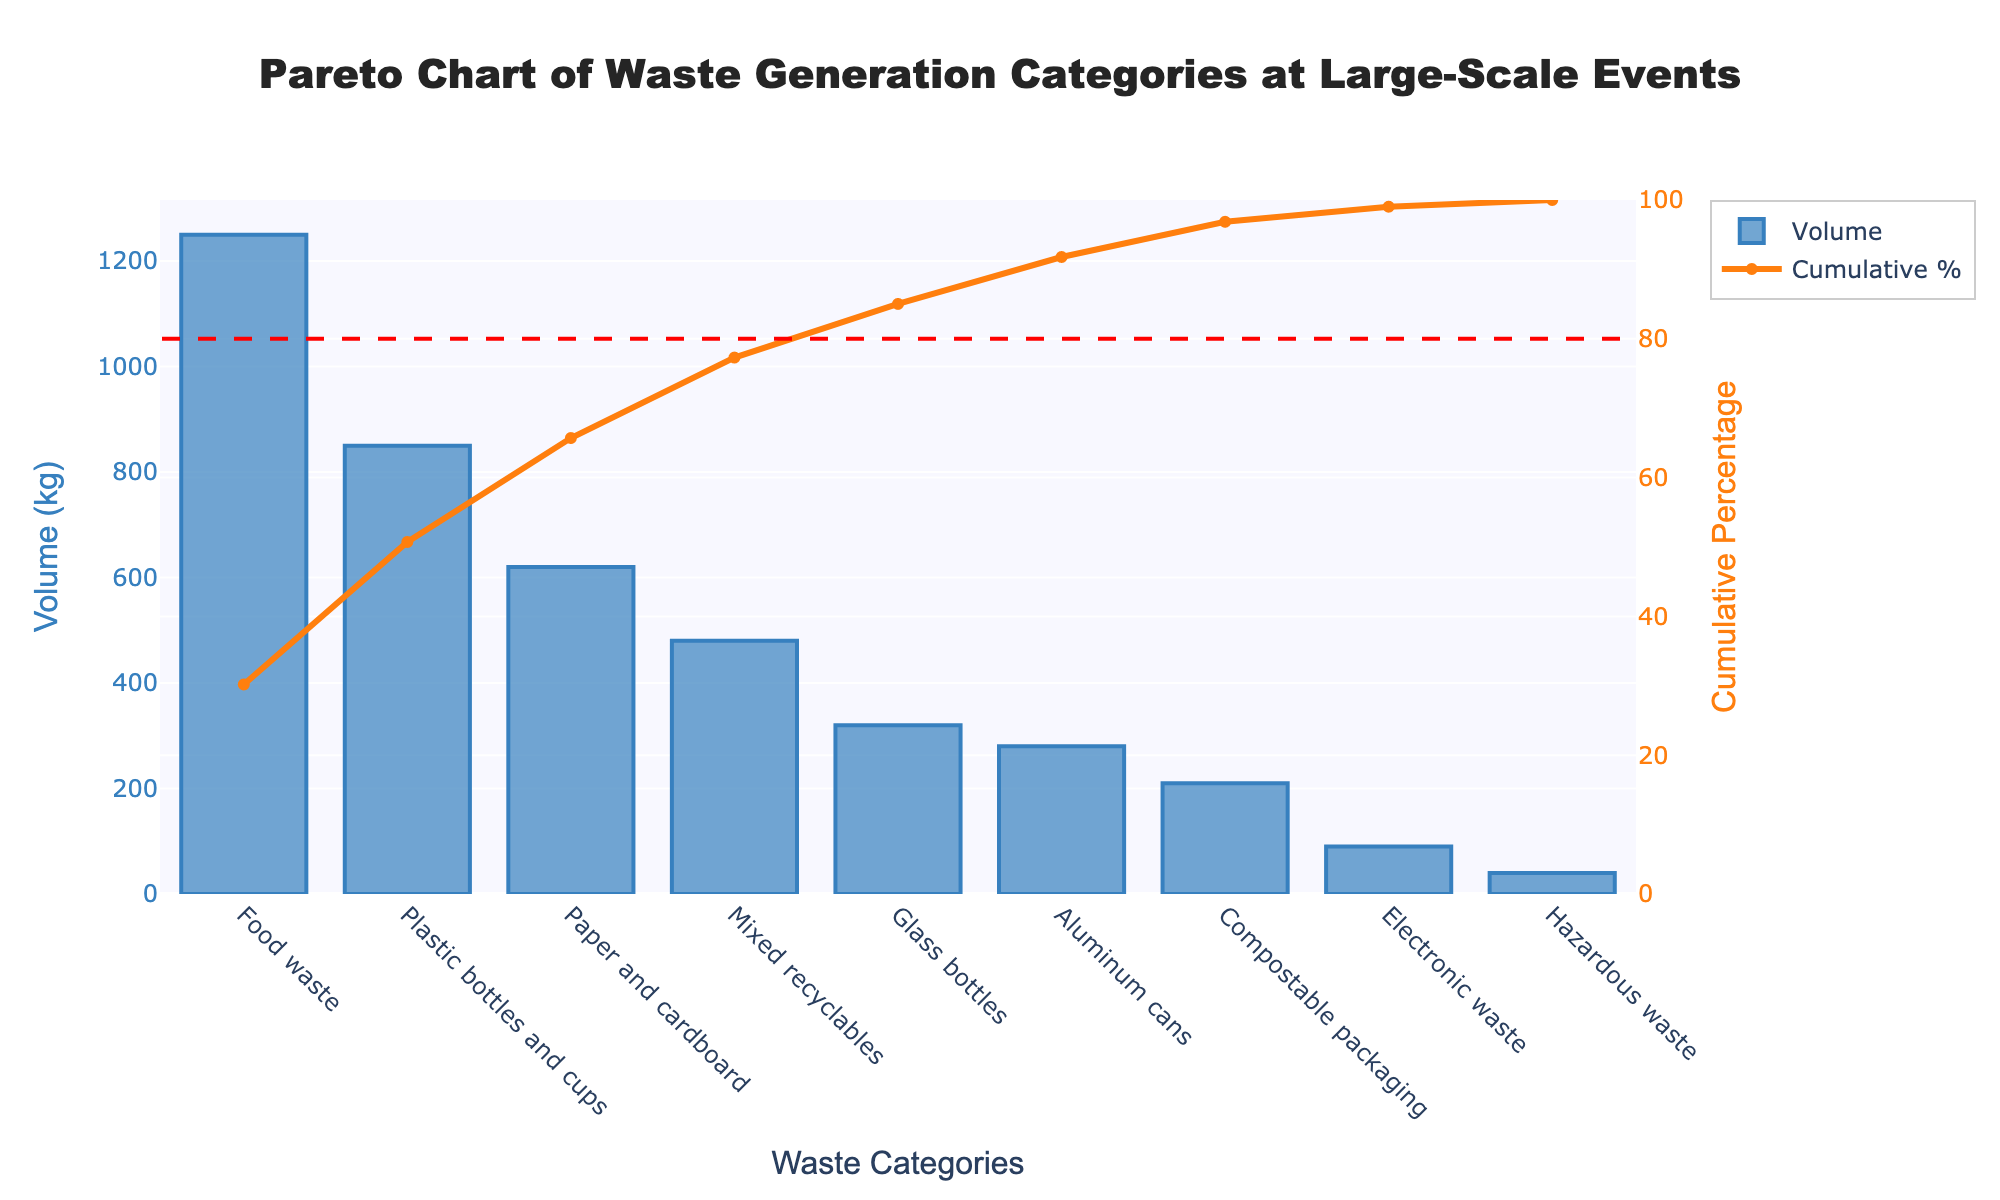Which waste category has the highest volume? Look at the bars in the Pareto chart and identify the one with the largest height. The highest volume category is Food waste.
Answer: Food waste What is the cumulative percentage for Plastic bottles and cups? Find the cumulative percentage value corresponding to Plastic bottles and cups. This value is given on the secondary y-axis (Cumulative Percentage).
Answer: 54.84% Which waste category has the lowest volume? Look at the bars and identify the one with the smallest height. The lowest volume corresponds to Electronic waste.
Answer: Electronic waste What is the total volume of Food waste and Plastic bottles and cups combined? Locate the volumes for Food waste and Plastic bottles and cups. Summing these values: 1250 (Food waste) + 850 (Plastic bottles and cups) = 2100 kg.
Answer: 2100 kg Which three categories together account for approximately 80% of the waste? Find the categories whose cumulative percentage total is closest to 80%. The cumulative percentages are: Food waste (35.56%), Plastic bottles and cups (54.84%), and Paper and cardboard (72.44%). Adding these, they account for approximately 80%.
Answer: Food waste, Plastic bottles and cups, Paper and cardboard How much more waste does Mixed recyclables generate compared to Glass bottles? Locate the volumes for Mixed recyclables and Glass bottles. Subtract the volume of Glass bottles from Mixed recyclables: 480 (Mixed recyclables) - 320 (Glass bottles) = 160 kg.
Answer: 160 kg Is there any category that contributes less than 5% to the total waste? Calculate 5% of the total waste volume by summing up all volumes and then identifying categories with cumulative percentage below 5%. The total volume is 4140 kg, so 5% of 4140 is 207 kg. Only Electronic waste (90 kg) and Hazardous waste (40 kg) contribute less than this amount.
Answer: Yes What is the cumulative percentage after including Compostable packaging? Locate Compostable packaging on the x-axis and find its cumulative percentage on the secondary y-axis.
Answer: 95.16% How does the volume of Aluminum cans compare to Compostable packaging? Compare the volumes directly. Aluminum cans have a volume of 280 kg, and Compostable packaging has 210 kg.
Answer: Aluminum cans have a higher volume What is the total volume for all categories combined? Sum the volumes of all categories: 1250 + 850 + 620 + 480 + 320 + 280 + 210 + 90 + 40 = 4140 kg.
Answer: 4140 kg 